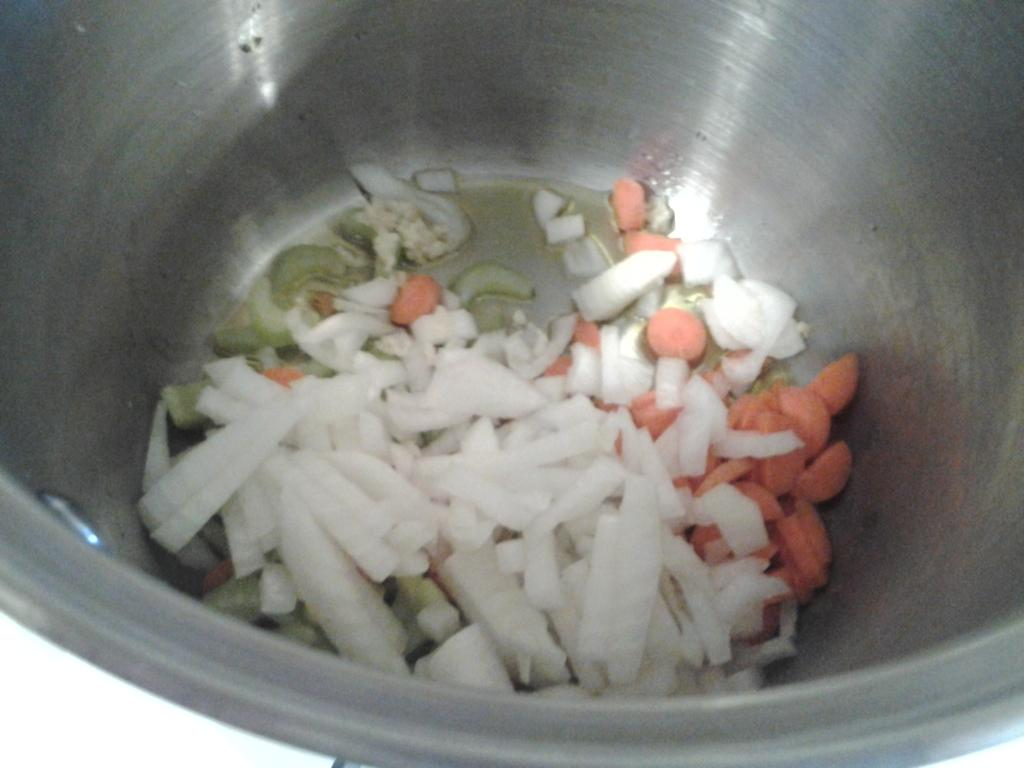What type of food is visible in the image? There are vegetables in the image. How are the vegetables arranged or contained in the image? The vegetables are in a vessel. What school is visible in the image? There is no school present in the image; it features vegetables in a vessel. What observation can be made about the vegetables in the image? Since the conversation is based on the provided facts, we cannot make any observations beyond the fact that there are vegetables in a vessel. 